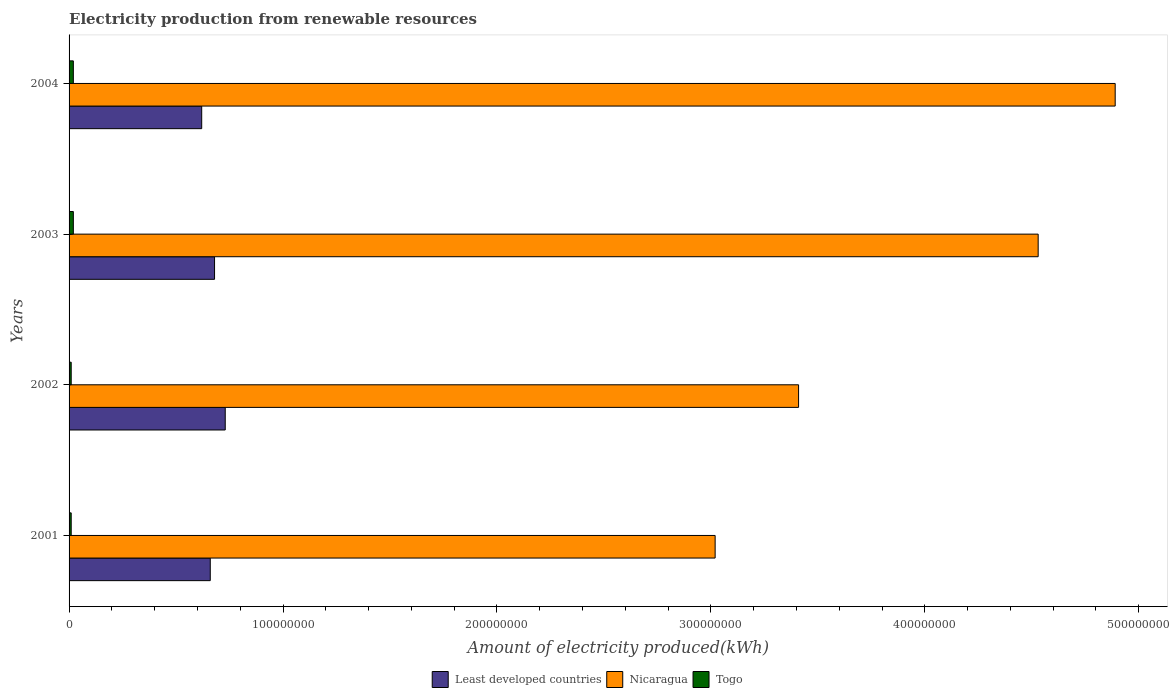How many different coloured bars are there?
Provide a succinct answer. 3. How many groups of bars are there?
Your response must be concise. 4. Are the number of bars on each tick of the Y-axis equal?
Ensure brevity in your answer.  Yes. How many bars are there on the 1st tick from the bottom?
Keep it short and to the point. 3. What is the label of the 3rd group of bars from the top?
Offer a very short reply. 2002. What is the amount of electricity produced in Nicaragua in 2001?
Provide a short and direct response. 3.02e+08. Across all years, what is the maximum amount of electricity produced in Least developed countries?
Give a very brief answer. 7.30e+07. Across all years, what is the minimum amount of electricity produced in Nicaragua?
Give a very brief answer. 3.02e+08. In which year was the amount of electricity produced in Nicaragua maximum?
Offer a terse response. 2004. What is the total amount of electricity produced in Nicaragua in the graph?
Give a very brief answer. 1.58e+09. What is the difference between the amount of electricity produced in Least developed countries in 2003 and the amount of electricity produced in Nicaragua in 2002?
Ensure brevity in your answer.  -2.73e+08. What is the average amount of electricity produced in Least developed countries per year?
Offer a terse response. 6.72e+07. In the year 2001, what is the difference between the amount of electricity produced in Togo and amount of electricity produced in Least developed countries?
Ensure brevity in your answer.  -6.50e+07. In how many years, is the amount of electricity produced in Togo greater than 340000000 kWh?
Ensure brevity in your answer.  0. What is the ratio of the amount of electricity produced in Least developed countries in 2001 to that in 2004?
Provide a short and direct response. 1.06. Is the amount of electricity produced in Least developed countries in 2002 less than that in 2004?
Ensure brevity in your answer.  No. Is the difference between the amount of electricity produced in Togo in 2003 and 2004 greater than the difference between the amount of electricity produced in Least developed countries in 2003 and 2004?
Offer a terse response. No. What is the difference between the highest and the lowest amount of electricity produced in Nicaragua?
Give a very brief answer. 1.87e+08. Is the sum of the amount of electricity produced in Togo in 2001 and 2002 greater than the maximum amount of electricity produced in Least developed countries across all years?
Your answer should be compact. No. What does the 2nd bar from the top in 2001 represents?
Your answer should be very brief. Nicaragua. What does the 3rd bar from the bottom in 2001 represents?
Keep it short and to the point. Togo. Is it the case that in every year, the sum of the amount of electricity produced in Togo and amount of electricity produced in Least developed countries is greater than the amount of electricity produced in Nicaragua?
Ensure brevity in your answer.  No. How many bars are there?
Your response must be concise. 12. What is the difference between two consecutive major ticks on the X-axis?
Your response must be concise. 1.00e+08. Are the values on the major ticks of X-axis written in scientific E-notation?
Offer a terse response. No. Does the graph contain grids?
Your answer should be very brief. No. Where does the legend appear in the graph?
Provide a short and direct response. Bottom center. How many legend labels are there?
Provide a short and direct response. 3. What is the title of the graph?
Offer a terse response. Electricity production from renewable resources. Does "French Polynesia" appear as one of the legend labels in the graph?
Your answer should be compact. No. What is the label or title of the X-axis?
Provide a succinct answer. Amount of electricity produced(kWh). What is the label or title of the Y-axis?
Provide a short and direct response. Years. What is the Amount of electricity produced(kWh) in Least developed countries in 2001?
Offer a very short reply. 6.60e+07. What is the Amount of electricity produced(kWh) of Nicaragua in 2001?
Offer a very short reply. 3.02e+08. What is the Amount of electricity produced(kWh) in Togo in 2001?
Ensure brevity in your answer.  1.00e+06. What is the Amount of electricity produced(kWh) in Least developed countries in 2002?
Ensure brevity in your answer.  7.30e+07. What is the Amount of electricity produced(kWh) in Nicaragua in 2002?
Make the answer very short. 3.41e+08. What is the Amount of electricity produced(kWh) in Least developed countries in 2003?
Your response must be concise. 6.80e+07. What is the Amount of electricity produced(kWh) in Nicaragua in 2003?
Provide a succinct answer. 4.53e+08. What is the Amount of electricity produced(kWh) of Togo in 2003?
Your response must be concise. 2.00e+06. What is the Amount of electricity produced(kWh) in Least developed countries in 2004?
Make the answer very short. 6.20e+07. What is the Amount of electricity produced(kWh) of Nicaragua in 2004?
Make the answer very short. 4.89e+08. Across all years, what is the maximum Amount of electricity produced(kWh) in Least developed countries?
Provide a succinct answer. 7.30e+07. Across all years, what is the maximum Amount of electricity produced(kWh) of Nicaragua?
Offer a very short reply. 4.89e+08. Across all years, what is the minimum Amount of electricity produced(kWh) of Least developed countries?
Make the answer very short. 6.20e+07. Across all years, what is the minimum Amount of electricity produced(kWh) in Nicaragua?
Provide a short and direct response. 3.02e+08. What is the total Amount of electricity produced(kWh) of Least developed countries in the graph?
Keep it short and to the point. 2.69e+08. What is the total Amount of electricity produced(kWh) of Nicaragua in the graph?
Offer a very short reply. 1.58e+09. What is the difference between the Amount of electricity produced(kWh) in Least developed countries in 2001 and that in 2002?
Ensure brevity in your answer.  -7.00e+06. What is the difference between the Amount of electricity produced(kWh) of Nicaragua in 2001 and that in 2002?
Keep it short and to the point. -3.90e+07. What is the difference between the Amount of electricity produced(kWh) in Togo in 2001 and that in 2002?
Provide a succinct answer. 0. What is the difference between the Amount of electricity produced(kWh) in Nicaragua in 2001 and that in 2003?
Provide a short and direct response. -1.51e+08. What is the difference between the Amount of electricity produced(kWh) in Togo in 2001 and that in 2003?
Provide a succinct answer. -1.00e+06. What is the difference between the Amount of electricity produced(kWh) in Least developed countries in 2001 and that in 2004?
Provide a succinct answer. 4.00e+06. What is the difference between the Amount of electricity produced(kWh) in Nicaragua in 2001 and that in 2004?
Offer a very short reply. -1.87e+08. What is the difference between the Amount of electricity produced(kWh) in Togo in 2001 and that in 2004?
Offer a terse response. -1.00e+06. What is the difference between the Amount of electricity produced(kWh) in Least developed countries in 2002 and that in 2003?
Give a very brief answer. 5.00e+06. What is the difference between the Amount of electricity produced(kWh) in Nicaragua in 2002 and that in 2003?
Your answer should be compact. -1.12e+08. What is the difference between the Amount of electricity produced(kWh) in Least developed countries in 2002 and that in 2004?
Your response must be concise. 1.10e+07. What is the difference between the Amount of electricity produced(kWh) in Nicaragua in 2002 and that in 2004?
Keep it short and to the point. -1.48e+08. What is the difference between the Amount of electricity produced(kWh) of Togo in 2002 and that in 2004?
Make the answer very short. -1.00e+06. What is the difference between the Amount of electricity produced(kWh) in Least developed countries in 2003 and that in 2004?
Offer a very short reply. 6.00e+06. What is the difference between the Amount of electricity produced(kWh) in Nicaragua in 2003 and that in 2004?
Offer a terse response. -3.60e+07. What is the difference between the Amount of electricity produced(kWh) in Least developed countries in 2001 and the Amount of electricity produced(kWh) in Nicaragua in 2002?
Your answer should be compact. -2.75e+08. What is the difference between the Amount of electricity produced(kWh) in Least developed countries in 2001 and the Amount of electricity produced(kWh) in Togo in 2002?
Provide a succinct answer. 6.50e+07. What is the difference between the Amount of electricity produced(kWh) of Nicaragua in 2001 and the Amount of electricity produced(kWh) of Togo in 2002?
Your response must be concise. 3.01e+08. What is the difference between the Amount of electricity produced(kWh) in Least developed countries in 2001 and the Amount of electricity produced(kWh) in Nicaragua in 2003?
Keep it short and to the point. -3.87e+08. What is the difference between the Amount of electricity produced(kWh) of Least developed countries in 2001 and the Amount of electricity produced(kWh) of Togo in 2003?
Offer a terse response. 6.40e+07. What is the difference between the Amount of electricity produced(kWh) in Nicaragua in 2001 and the Amount of electricity produced(kWh) in Togo in 2003?
Offer a very short reply. 3.00e+08. What is the difference between the Amount of electricity produced(kWh) of Least developed countries in 2001 and the Amount of electricity produced(kWh) of Nicaragua in 2004?
Offer a very short reply. -4.23e+08. What is the difference between the Amount of electricity produced(kWh) in Least developed countries in 2001 and the Amount of electricity produced(kWh) in Togo in 2004?
Give a very brief answer. 6.40e+07. What is the difference between the Amount of electricity produced(kWh) of Nicaragua in 2001 and the Amount of electricity produced(kWh) of Togo in 2004?
Provide a short and direct response. 3.00e+08. What is the difference between the Amount of electricity produced(kWh) in Least developed countries in 2002 and the Amount of electricity produced(kWh) in Nicaragua in 2003?
Provide a succinct answer. -3.80e+08. What is the difference between the Amount of electricity produced(kWh) of Least developed countries in 2002 and the Amount of electricity produced(kWh) of Togo in 2003?
Provide a short and direct response. 7.10e+07. What is the difference between the Amount of electricity produced(kWh) in Nicaragua in 2002 and the Amount of electricity produced(kWh) in Togo in 2003?
Your answer should be very brief. 3.39e+08. What is the difference between the Amount of electricity produced(kWh) in Least developed countries in 2002 and the Amount of electricity produced(kWh) in Nicaragua in 2004?
Provide a succinct answer. -4.16e+08. What is the difference between the Amount of electricity produced(kWh) in Least developed countries in 2002 and the Amount of electricity produced(kWh) in Togo in 2004?
Provide a short and direct response. 7.10e+07. What is the difference between the Amount of electricity produced(kWh) of Nicaragua in 2002 and the Amount of electricity produced(kWh) of Togo in 2004?
Provide a short and direct response. 3.39e+08. What is the difference between the Amount of electricity produced(kWh) in Least developed countries in 2003 and the Amount of electricity produced(kWh) in Nicaragua in 2004?
Offer a very short reply. -4.21e+08. What is the difference between the Amount of electricity produced(kWh) in Least developed countries in 2003 and the Amount of electricity produced(kWh) in Togo in 2004?
Ensure brevity in your answer.  6.60e+07. What is the difference between the Amount of electricity produced(kWh) of Nicaragua in 2003 and the Amount of electricity produced(kWh) of Togo in 2004?
Make the answer very short. 4.51e+08. What is the average Amount of electricity produced(kWh) in Least developed countries per year?
Your response must be concise. 6.72e+07. What is the average Amount of electricity produced(kWh) in Nicaragua per year?
Your answer should be very brief. 3.96e+08. What is the average Amount of electricity produced(kWh) of Togo per year?
Keep it short and to the point. 1.50e+06. In the year 2001, what is the difference between the Amount of electricity produced(kWh) in Least developed countries and Amount of electricity produced(kWh) in Nicaragua?
Give a very brief answer. -2.36e+08. In the year 2001, what is the difference between the Amount of electricity produced(kWh) of Least developed countries and Amount of electricity produced(kWh) of Togo?
Provide a short and direct response. 6.50e+07. In the year 2001, what is the difference between the Amount of electricity produced(kWh) of Nicaragua and Amount of electricity produced(kWh) of Togo?
Your response must be concise. 3.01e+08. In the year 2002, what is the difference between the Amount of electricity produced(kWh) in Least developed countries and Amount of electricity produced(kWh) in Nicaragua?
Give a very brief answer. -2.68e+08. In the year 2002, what is the difference between the Amount of electricity produced(kWh) in Least developed countries and Amount of electricity produced(kWh) in Togo?
Offer a terse response. 7.20e+07. In the year 2002, what is the difference between the Amount of electricity produced(kWh) in Nicaragua and Amount of electricity produced(kWh) in Togo?
Your answer should be very brief. 3.40e+08. In the year 2003, what is the difference between the Amount of electricity produced(kWh) in Least developed countries and Amount of electricity produced(kWh) in Nicaragua?
Provide a short and direct response. -3.85e+08. In the year 2003, what is the difference between the Amount of electricity produced(kWh) of Least developed countries and Amount of electricity produced(kWh) of Togo?
Give a very brief answer. 6.60e+07. In the year 2003, what is the difference between the Amount of electricity produced(kWh) of Nicaragua and Amount of electricity produced(kWh) of Togo?
Offer a very short reply. 4.51e+08. In the year 2004, what is the difference between the Amount of electricity produced(kWh) of Least developed countries and Amount of electricity produced(kWh) of Nicaragua?
Make the answer very short. -4.27e+08. In the year 2004, what is the difference between the Amount of electricity produced(kWh) in Least developed countries and Amount of electricity produced(kWh) in Togo?
Your answer should be compact. 6.00e+07. In the year 2004, what is the difference between the Amount of electricity produced(kWh) of Nicaragua and Amount of electricity produced(kWh) of Togo?
Your answer should be very brief. 4.87e+08. What is the ratio of the Amount of electricity produced(kWh) of Least developed countries in 2001 to that in 2002?
Ensure brevity in your answer.  0.9. What is the ratio of the Amount of electricity produced(kWh) in Nicaragua in 2001 to that in 2002?
Give a very brief answer. 0.89. What is the ratio of the Amount of electricity produced(kWh) of Least developed countries in 2001 to that in 2003?
Ensure brevity in your answer.  0.97. What is the ratio of the Amount of electricity produced(kWh) of Nicaragua in 2001 to that in 2003?
Provide a short and direct response. 0.67. What is the ratio of the Amount of electricity produced(kWh) in Togo in 2001 to that in 2003?
Offer a terse response. 0.5. What is the ratio of the Amount of electricity produced(kWh) of Least developed countries in 2001 to that in 2004?
Offer a very short reply. 1.06. What is the ratio of the Amount of electricity produced(kWh) in Nicaragua in 2001 to that in 2004?
Give a very brief answer. 0.62. What is the ratio of the Amount of electricity produced(kWh) of Togo in 2001 to that in 2004?
Provide a short and direct response. 0.5. What is the ratio of the Amount of electricity produced(kWh) in Least developed countries in 2002 to that in 2003?
Ensure brevity in your answer.  1.07. What is the ratio of the Amount of electricity produced(kWh) of Nicaragua in 2002 to that in 2003?
Offer a very short reply. 0.75. What is the ratio of the Amount of electricity produced(kWh) of Least developed countries in 2002 to that in 2004?
Provide a short and direct response. 1.18. What is the ratio of the Amount of electricity produced(kWh) in Nicaragua in 2002 to that in 2004?
Your answer should be very brief. 0.7. What is the ratio of the Amount of electricity produced(kWh) in Togo in 2002 to that in 2004?
Provide a short and direct response. 0.5. What is the ratio of the Amount of electricity produced(kWh) in Least developed countries in 2003 to that in 2004?
Offer a terse response. 1.1. What is the ratio of the Amount of electricity produced(kWh) of Nicaragua in 2003 to that in 2004?
Ensure brevity in your answer.  0.93. What is the ratio of the Amount of electricity produced(kWh) of Togo in 2003 to that in 2004?
Keep it short and to the point. 1. What is the difference between the highest and the second highest Amount of electricity produced(kWh) in Least developed countries?
Make the answer very short. 5.00e+06. What is the difference between the highest and the second highest Amount of electricity produced(kWh) in Nicaragua?
Offer a terse response. 3.60e+07. What is the difference between the highest and the lowest Amount of electricity produced(kWh) in Least developed countries?
Give a very brief answer. 1.10e+07. What is the difference between the highest and the lowest Amount of electricity produced(kWh) in Nicaragua?
Provide a short and direct response. 1.87e+08. What is the difference between the highest and the lowest Amount of electricity produced(kWh) in Togo?
Keep it short and to the point. 1.00e+06. 